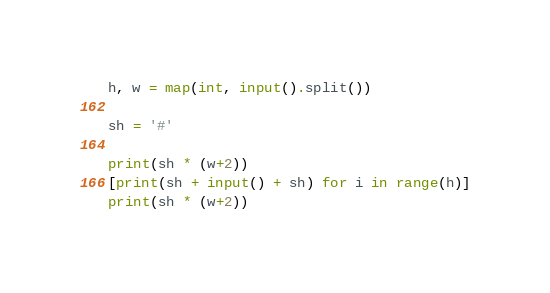<code> <loc_0><loc_0><loc_500><loc_500><_Python_>h, w = map(int, input().split())

sh = '#'

print(sh * (w+2))
[print(sh + input() + sh) for i in range(h)]
print(sh * (w+2))</code> 